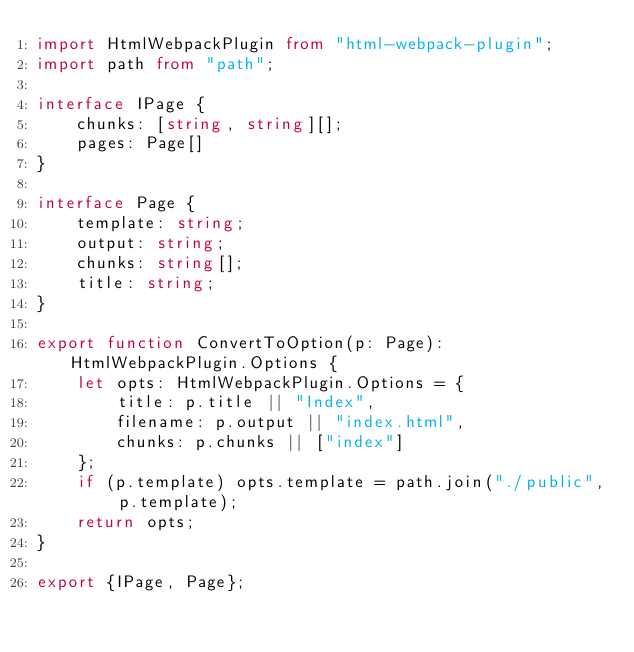<code> <loc_0><loc_0><loc_500><loc_500><_TypeScript_>import HtmlWebpackPlugin from "html-webpack-plugin";
import path from "path";

interface IPage {
    chunks: [string, string][];
    pages: Page[]
}

interface Page {
    template: string;
    output: string;
    chunks: string[];
    title: string;
}

export function ConvertToOption(p: Page): HtmlWebpackPlugin.Options {
    let opts: HtmlWebpackPlugin.Options = {
        title: p.title || "Index",
        filename: p.output || "index.html",
        chunks: p.chunks || ["index"]
    };
    if (p.template) opts.template = path.join("./public", p.template);
    return opts;
}

export {IPage, Page};</code> 